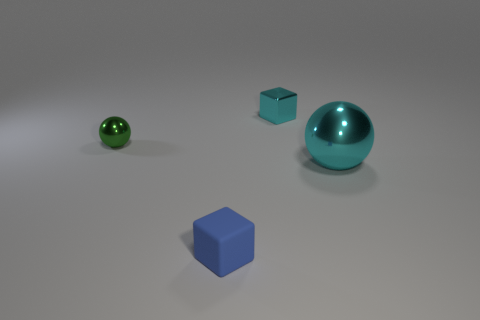Is there a small sphere of the same color as the big shiny thing?
Ensure brevity in your answer.  No. What shape is the green thing that is the same size as the cyan cube?
Keep it short and to the point. Sphere. What color is the block in front of the tiny green sphere?
Keep it short and to the point. Blue. Is there a cyan metallic sphere that is behind the metal sphere that is on the left side of the cyan shiny ball?
Your answer should be very brief. No. How many things are small metal things that are on the left side of the tiny matte cube or small cyan metal cubes?
Ensure brevity in your answer.  2. Is there any other thing that has the same size as the cyan metal block?
Your answer should be very brief. Yes. There is a small block on the right side of the cube that is in front of the cyan sphere; what is its material?
Your answer should be compact. Metal. Is the number of blue matte blocks in front of the tiny blue block the same as the number of small green spheres on the right side of the big ball?
Offer a very short reply. Yes. What number of objects are cyan things on the left side of the large cyan thing or metal objects that are in front of the tiny cyan object?
Give a very brief answer. 3. There is a thing that is both behind the large cyan thing and left of the tiny cyan metal object; what is its material?
Ensure brevity in your answer.  Metal. 